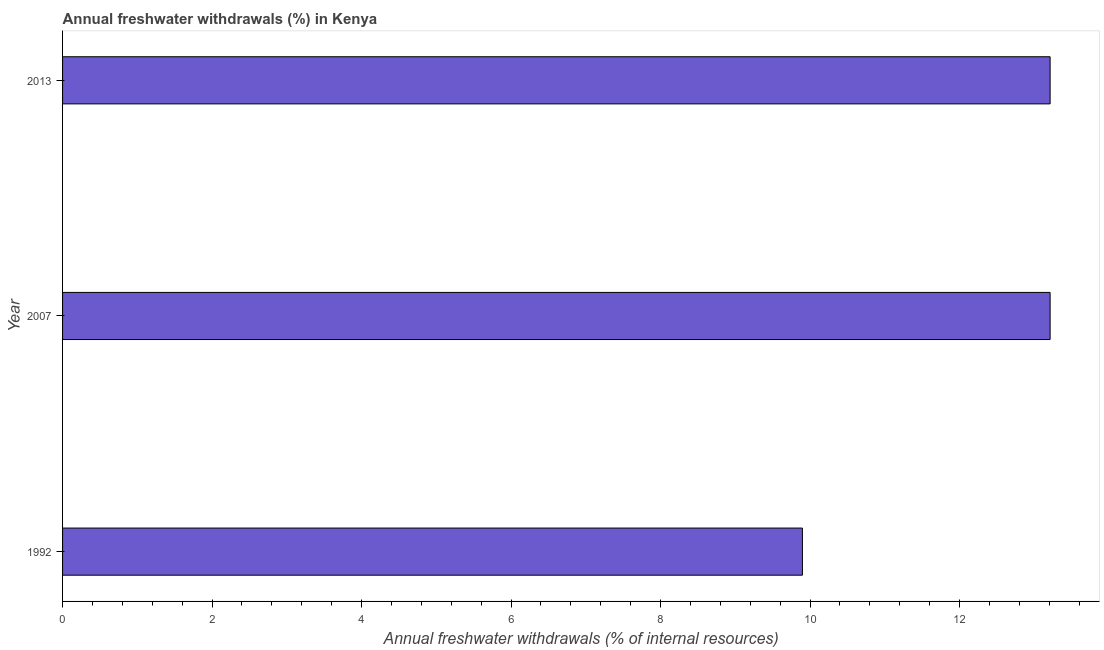Does the graph contain any zero values?
Provide a short and direct response. No. What is the title of the graph?
Give a very brief answer. Annual freshwater withdrawals (%) in Kenya. What is the label or title of the X-axis?
Offer a terse response. Annual freshwater withdrawals (% of internal resources). What is the annual freshwater withdrawals in 2007?
Your answer should be very brief. 13.21. Across all years, what is the maximum annual freshwater withdrawals?
Offer a terse response. 13.21. Across all years, what is the minimum annual freshwater withdrawals?
Offer a very short reply. 9.9. In which year was the annual freshwater withdrawals minimum?
Your answer should be compact. 1992. What is the sum of the annual freshwater withdrawals?
Your answer should be compact. 36.32. What is the difference between the annual freshwater withdrawals in 1992 and 2013?
Your response must be concise. -3.31. What is the average annual freshwater withdrawals per year?
Your answer should be very brief. 12.11. What is the median annual freshwater withdrawals?
Give a very brief answer. 13.21. Do a majority of the years between 2007 and 2013 (inclusive) have annual freshwater withdrawals greater than 8.4 %?
Give a very brief answer. Yes. What is the ratio of the annual freshwater withdrawals in 1992 to that in 2007?
Make the answer very short. 0.75. Is the difference between the annual freshwater withdrawals in 1992 and 2013 greater than the difference between any two years?
Keep it short and to the point. Yes. What is the difference between the highest and the second highest annual freshwater withdrawals?
Provide a succinct answer. 0. Is the sum of the annual freshwater withdrawals in 1992 and 2013 greater than the maximum annual freshwater withdrawals across all years?
Offer a very short reply. Yes. What is the difference between the highest and the lowest annual freshwater withdrawals?
Make the answer very short. 3.31. In how many years, is the annual freshwater withdrawals greater than the average annual freshwater withdrawals taken over all years?
Your answer should be very brief. 2. How many bars are there?
Your answer should be very brief. 3. Are all the bars in the graph horizontal?
Your answer should be very brief. Yes. How many years are there in the graph?
Your answer should be compact. 3. What is the Annual freshwater withdrawals (% of internal resources) in 1992?
Provide a short and direct response. 9.9. What is the Annual freshwater withdrawals (% of internal resources) in 2007?
Keep it short and to the point. 13.21. What is the Annual freshwater withdrawals (% of internal resources) of 2013?
Keep it short and to the point. 13.21. What is the difference between the Annual freshwater withdrawals (% of internal resources) in 1992 and 2007?
Give a very brief answer. -3.31. What is the difference between the Annual freshwater withdrawals (% of internal resources) in 1992 and 2013?
Your answer should be compact. -3.31. What is the ratio of the Annual freshwater withdrawals (% of internal resources) in 1992 to that in 2007?
Give a very brief answer. 0.75. What is the ratio of the Annual freshwater withdrawals (% of internal resources) in 1992 to that in 2013?
Your response must be concise. 0.75. What is the ratio of the Annual freshwater withdrawals (% of internal resources) in 2007 to that in 2013?
Give a very brief answer. 1. 